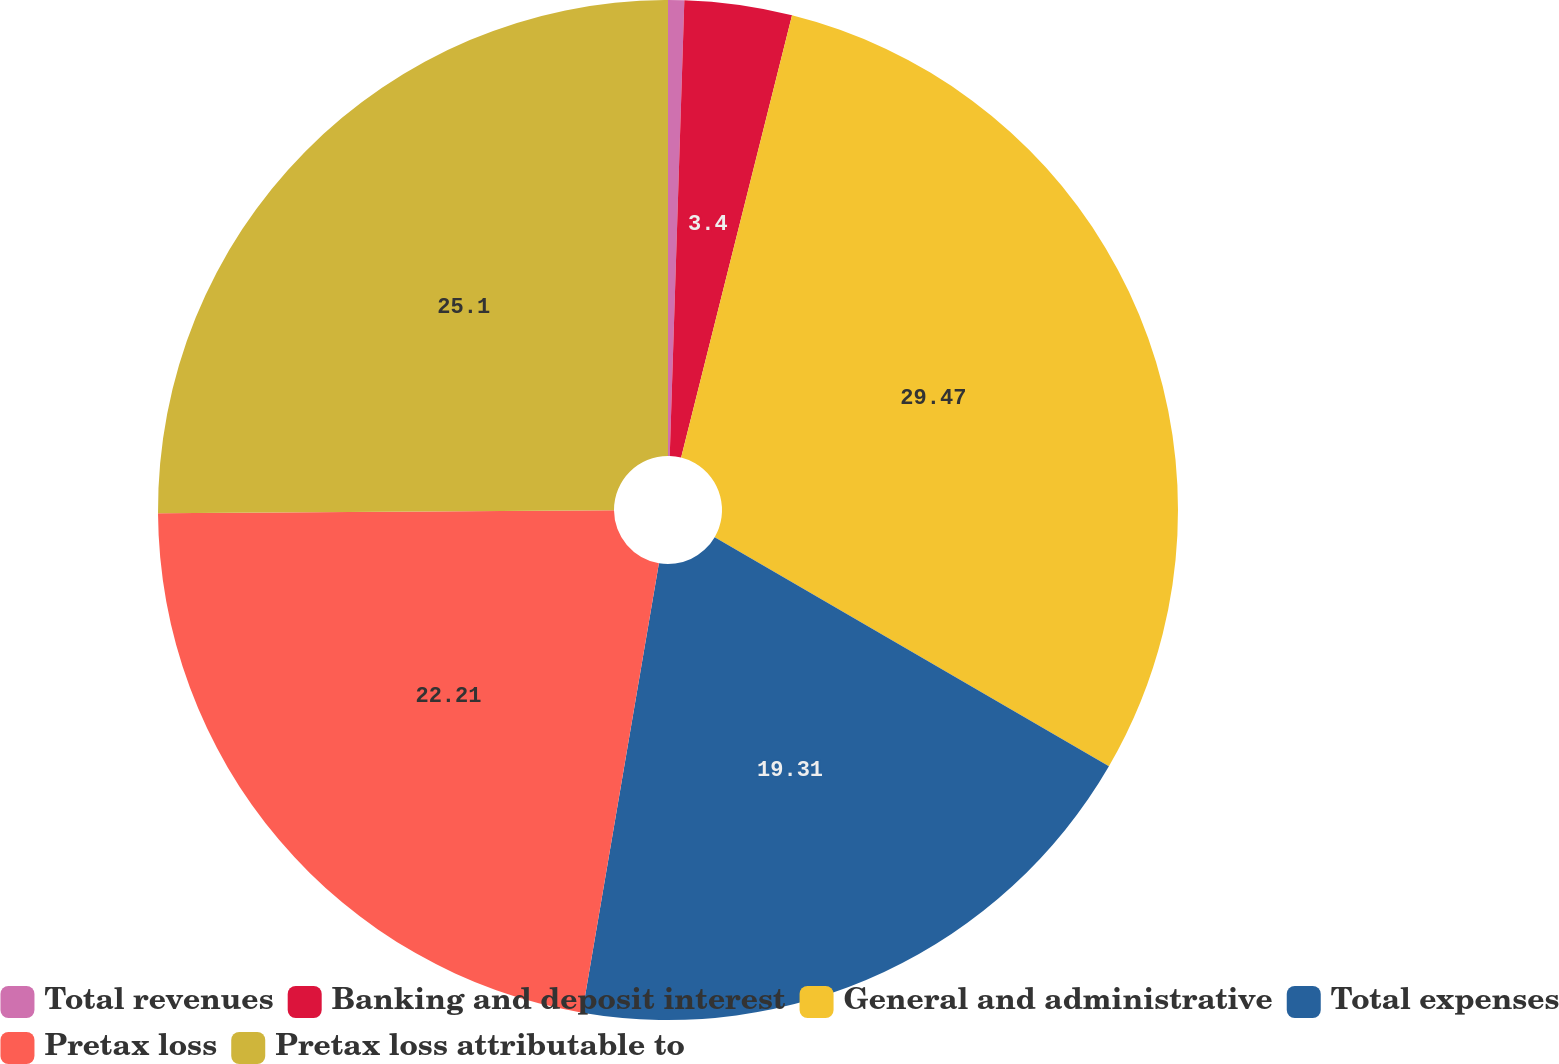Convert chart. <chart><loc_0><loc_0><loc_500><loc_500><pie_chart><fcel>Total revenues<fcel>Banking and deposit interest<fcel>General and administrative<fcel>Total expenses<fcel>Pretax loss<fcel>Pretax loss attributable to<nl><fcel>0.51%<fcel>3.4%<fcel>29.47%<fcel>19.31%<fcel>22.21%<fcel>25.1%<nl></chart> 